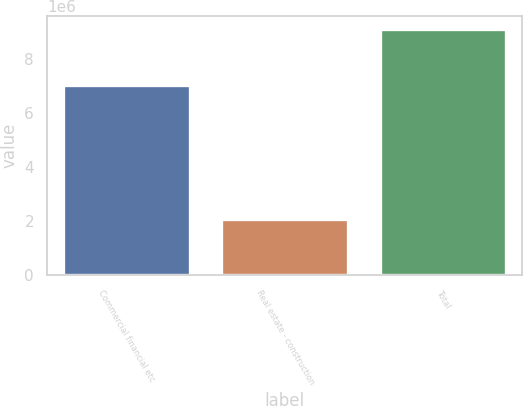<chart> <loc_0><loc_0><loc_500><loc_500><bar_chart><fcel>Commercial financial etc<fcel>Real estate - construction<fcel>Total<nl><fcel>7.0414e+06<fcel>2.07444e+06<fcel>9.11585e+06<nl></chart> 